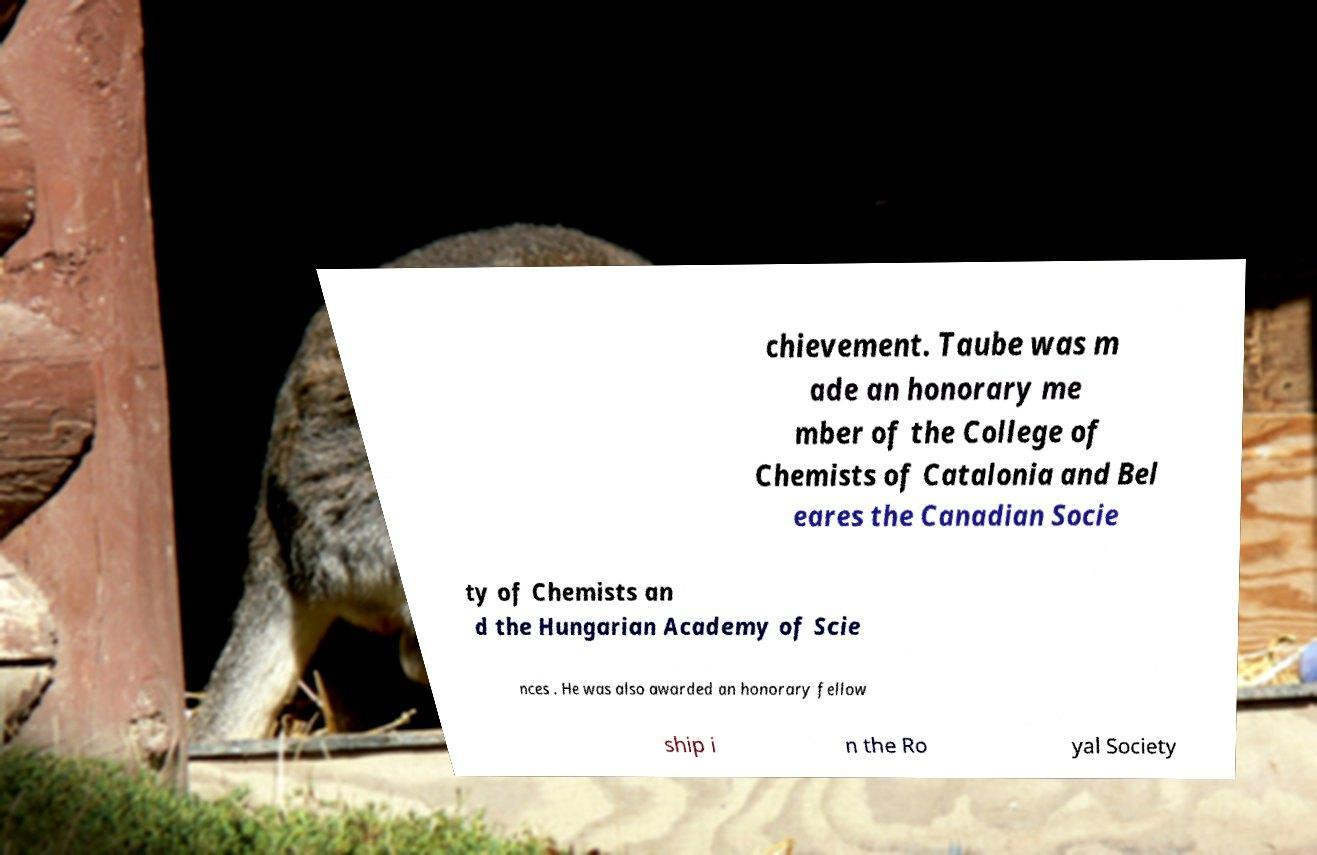I need the written content from this picture converted into text. Can you do that? chievement. Taube was m ade an honorary me mber of the College of Chemists of Catalonia and Bel eares the Canadian Socie ty of Chemists an d the Hungarian Academy of Scie nces . He was also awarded an honorary fellow ship i n the Ro yal Society 